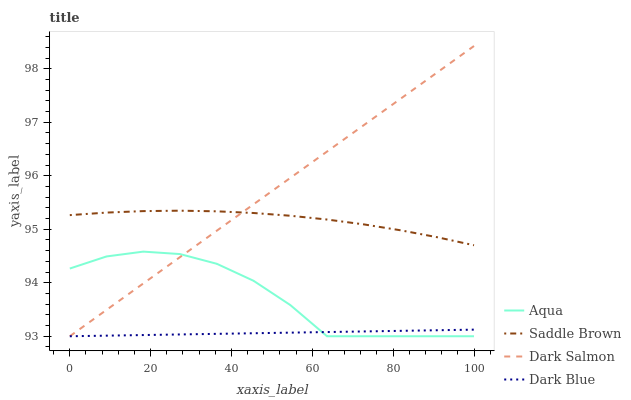Does Dark Blue have the minimum area under the curve?
Answer yes or no. Yes. Does Dark Salmon have the maximum area under the curve?
Answer yes or no. Yes. Does Aqua have the minimum area under the curve?
Answer yes or no. No. Does Aqua have the maximum area under the curve?
Answer yes or no. No. Is Dark Blue the smoothest?
Answer yes or no. Yes. Is Aqua the roughest?
Answer yes or no. Yes. Is Saddle Brown the smoothest?
Answer yes or no. No. Is Saddle Brown the roughest?
Answer yes or no. No. Does Dark Blue have the lowest value?
Answer yes or no. Yes. Does Saddle Brown have the lowest value?
Answer yes or no. No. Does Dark Salmon have the highest value?
Answer yes or no. Yes. Does Aqua have the highest value?
Answer yes or no. No. Is Aqua less than Saddle Brown?
Answer yes or no. Yes. Is Saddle Brown greater than Aqua?
Answer yes or no. Yes. Does Dark Salmon intersect Saddle Brown?
Answer yes or no. Yes. Is Dark Salmon less than Saddle Brown?
Answer yes or no. No. Is Dark Salmon greater than Saddle Brown?
Answer yes or no. No. Does Aqua intersect Saddle Brown?
Answer yes or no. No. 